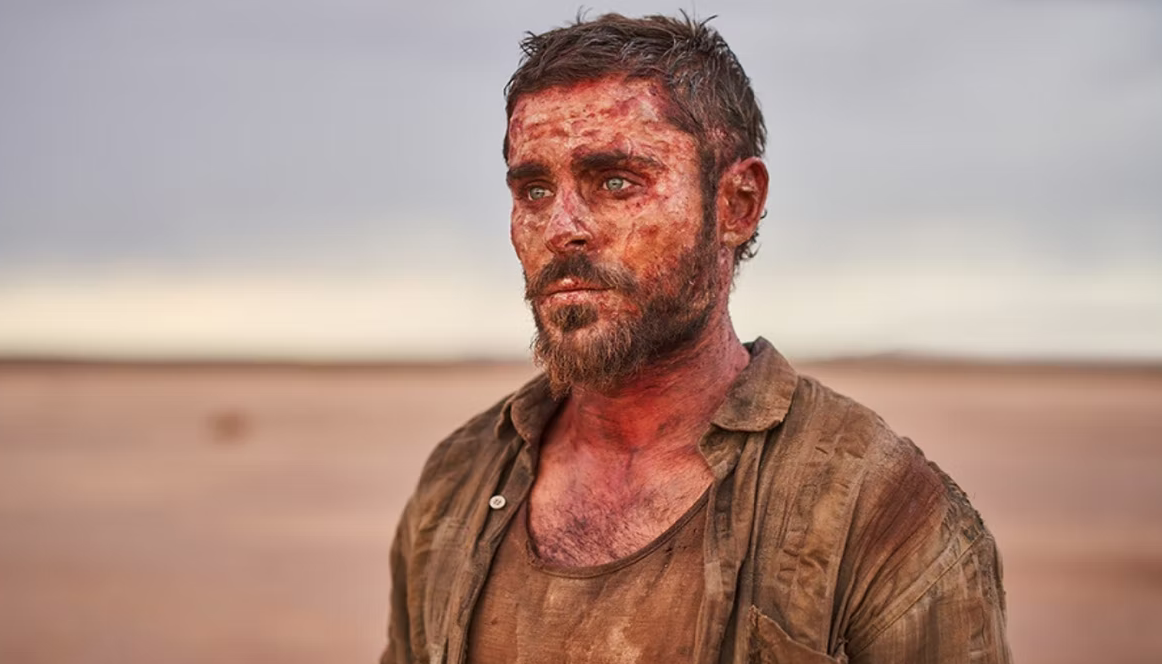What kind of emotions does this image evoke and why? The image evokes a profound sense of perseverance and resilience. The visible exhaustion and injuries on the character's face signify a long and arduous journey through adversity. The barren, endless desert backdrop reinforces the isolation and desperation of his plight. Yet, amidst these harsh realities, there's also a subtle undercurrent of hope and tenacity, as he stands tall despite his apparent hardships. The viewer is drawn to empathize with his struggle and admire the unyielding human spirit depicted in this moment. 